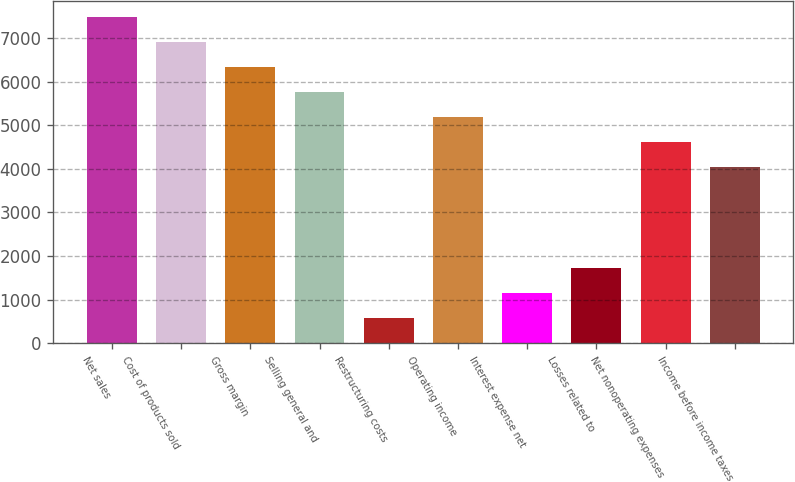<chart> <loc_0><loc_0><loc_500><loc_500><bar_chart><fcel>Net sales<fcel>Cost of products sold<fcel>Gross margin<fcel>Selling general and<fcel>Restructuring costs<fcel>Operating income<fcel>Interest expense net<fcel>Losses related to<fcel>Net nonoperating expenses<fcel>Income before income taxes<nl><fcel>7484.71<fcel>6909.54<fcel>6334.37<fcel>5759.2<fcel>582.67<fcel>5184.03<fcel>1157.84<fcel>1733.01<fcel>4608.86<fcel>4033.69<nl></chart> 